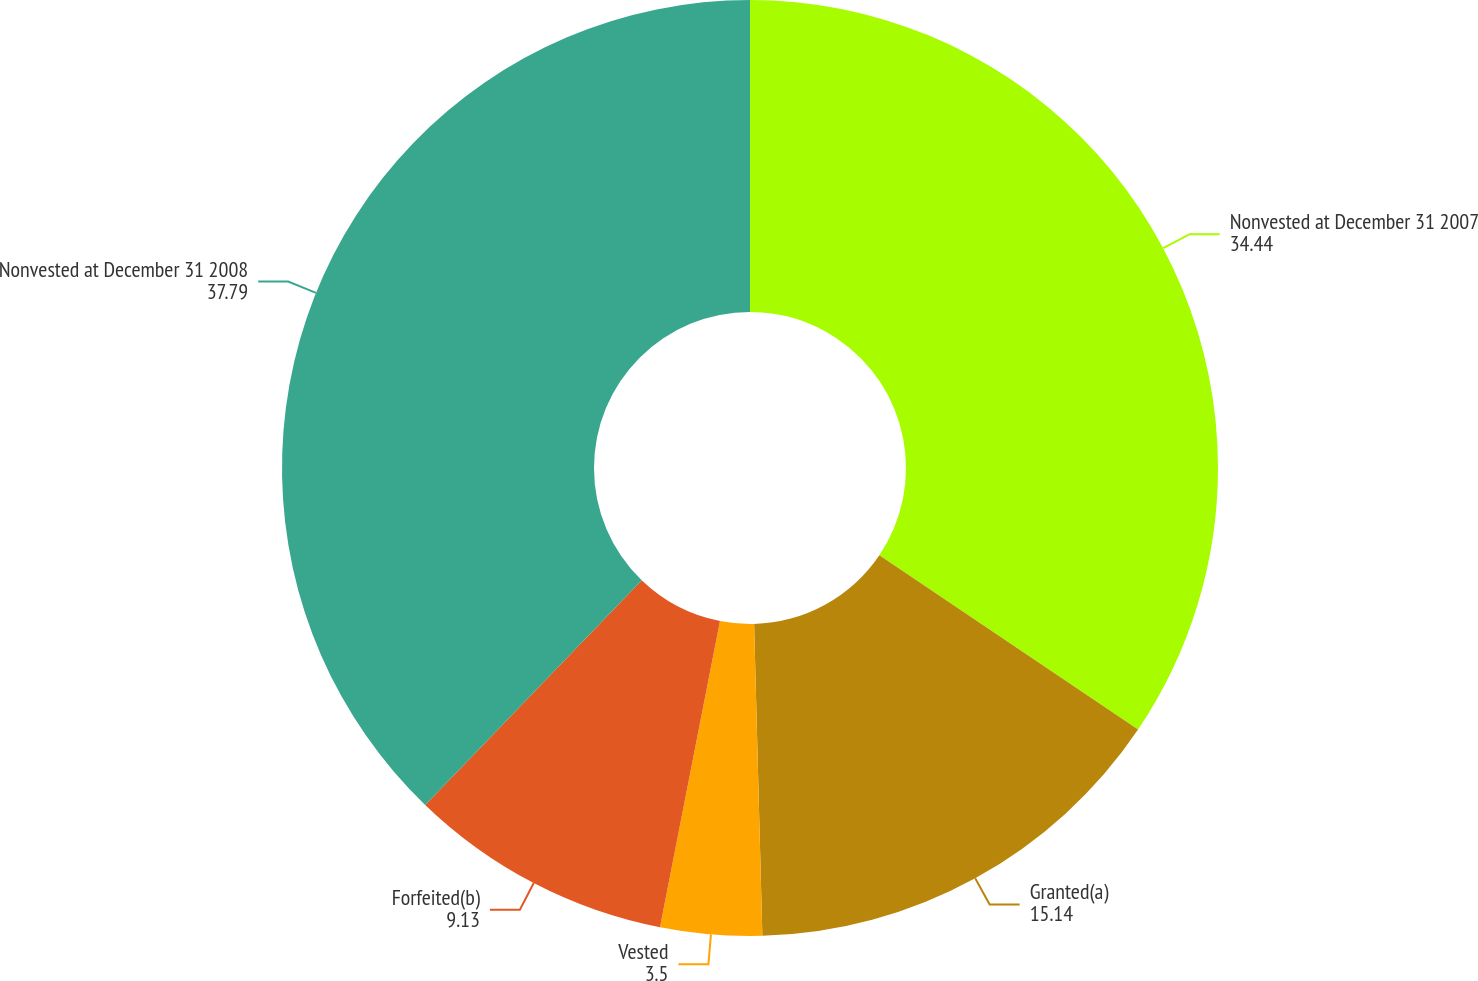Convert chart. <chart><loc_0><loc_0><loc_500><loc_500><pie_chart><fcel>Nonvested at December 31 2007<fcel>Granted(a)<fcel>Vested<fcel>Forfeited(b)<fcel>Nonvested at December 31 2008<nl><fcel>34.44%<fcel>15.14%<fcel>3.5%<fcel>9.13%<fcel>37.79%<nl></chart> 